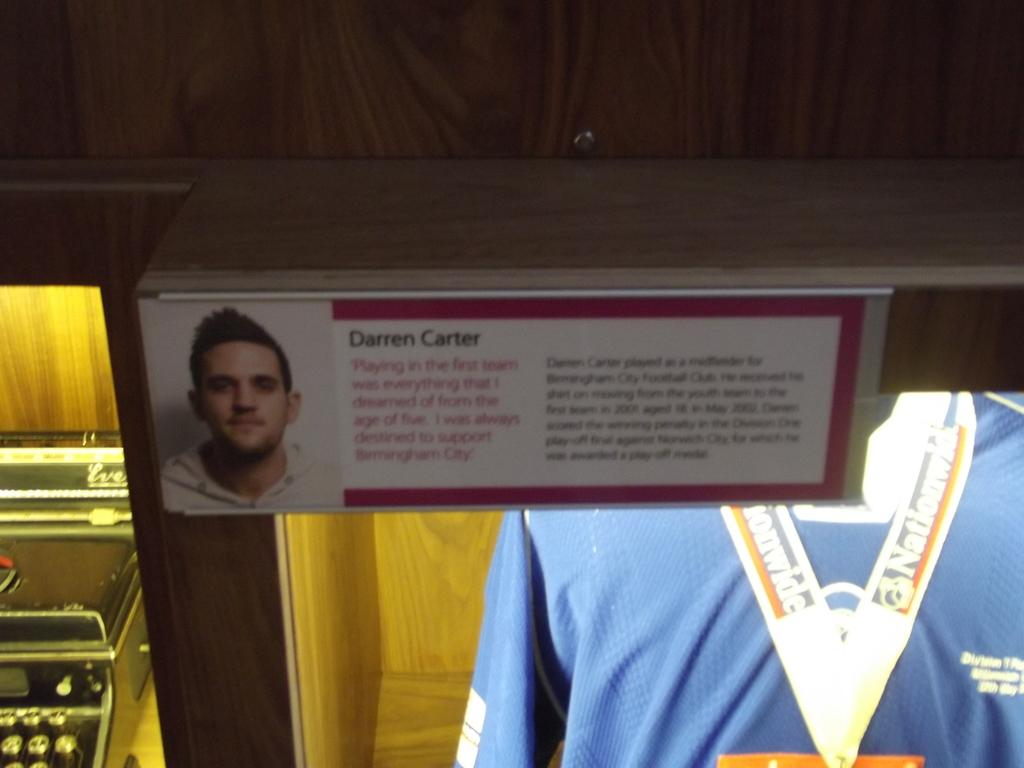<image>
Share a concise interpretation of the image provided. display case with jersey in it and sign showing it was for darren carter and showed he always supported birmingham city 